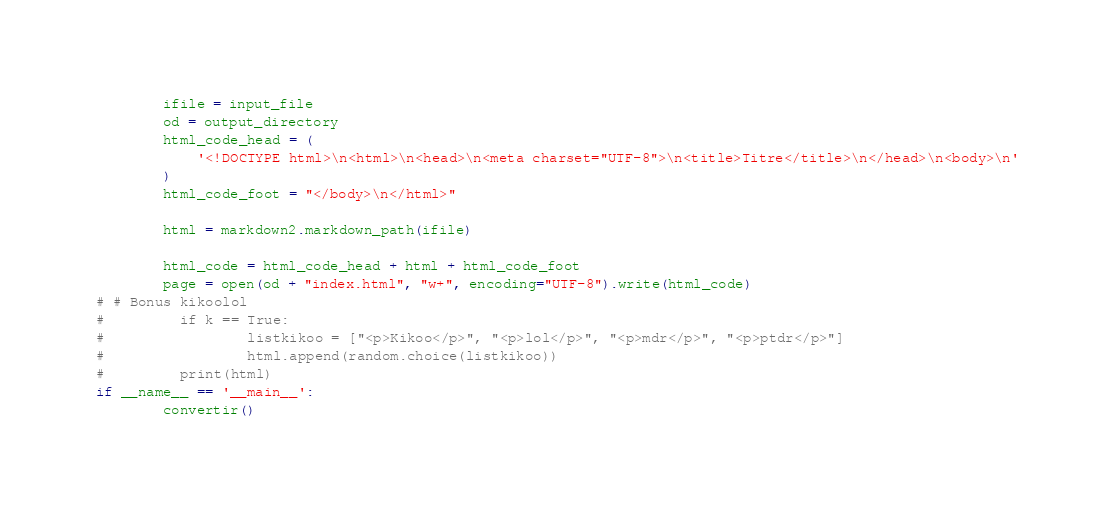<code> <loc_0><loc_0><loc_500><loc_500><_Python_>        ifile = input_file
        od = output_directory
        html_code_head = (
            '<!DOCTYPE html>\n<html>\n<head>\n<meta charset="UTF-8">\n<title>Titre</title>\n</head>\n<body>\n'
        )
        html_code_foot = "</body>\n</html>"
       
        html = markdown2.markdown_path(ifile)

        html_code = html_code_head + html + html_code_foot
        page = open(od + "index.html", "w+", encoding="UTF-8").write(html_code)
# # Bonus kikoolol
#         if k == True:
#                 listkikoo = ["<p>Kikoo</p>", "<p>lol</p>", "<p>mdr</p>", "<p>ptdr</p>"]
#                 html.append(random.choice(listkikoo))
#         print(html)
if __name__ == '__main__':
        convertir()</code> 